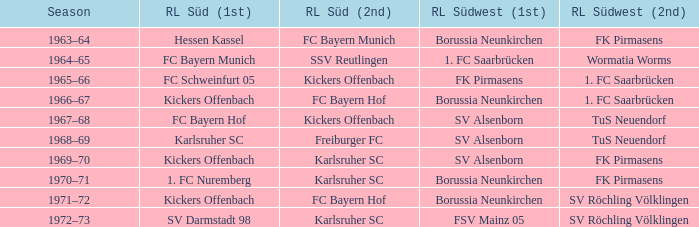Could you help me parse every detail presented in this table? {'header': ['Season', 'RL Süd (1st)', 'RL Süd (2nd)', 'RL Südwest (1st)', 'RL Südwest (2nd)'], 'rows': [['1963–64', 'Hessen Kassel', 'FC Bayern Munich', 'Borussia Neunkirchen', 'FK Pirmasens'], ['1964–65', 'FC Bayern Munich', 'SSV Reutlingen', '1. FC Saarbrücken', 'Wormatia Worms'], ['1965–66', 'FC Schweinfurt 05', 'Kickers Offenbach', 'FK Pirmasens', '1. FC Saarbrücken'], ['1966–67', 'Kickers Offenbach', 'FC Bayern Hof', 'Borussia Neunkirchen', '1. FC Saarbrücken'], ['1967–68', 'FC Bayern Hof', 'Kickers Offenbach', 'SV Alsenborn', 'TuS Neuendorf'], ['1968–69', 'Karlsruher SC', 'Freiburger FC', 'SV Alsenborn', 'TuS Neuendorf'], ['1969–70', 'Kickers Offenbach', 'Karlsruher SC', 'SV Alsenborn', 'FK Pirmasens'], ['1970–71', '1. FC Nuremberg', 'Karlsruher SC', 'Borussia Neunkirchen', 'FK Pirmasens'], ['1971–72', 'Kickers Offenbach', 'FC Bayern Hof', 'Borussia Neunkirchen', 'SV Röchling Völklingen'], ['1972–73', 'SV Darmstadt 98', 'Karlsruher SC', 'FSV Mainz 05', 'SV Röchling Völklingen']]} Who was rl süd (1st) during the time fk pirmasens was rl südwest (1st)? FC Schweinfurt 05. 